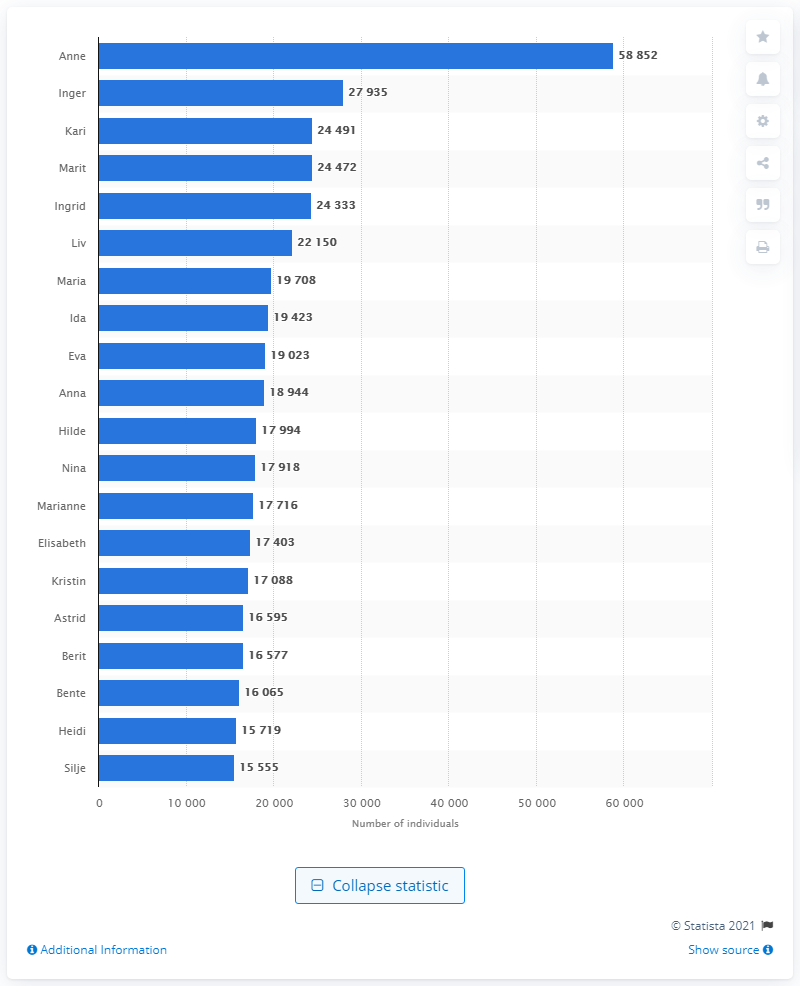Point out several critical features in this image. According to recent data, Inger and Kari were the second and third most popular names in Norway in 2020, respectively. In Norway in 2020, the most popular female name was Anne. 